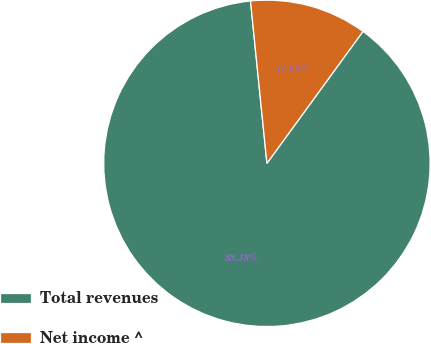<chart> <loc_0><loc_0><loc_500><loc_500><pie_chart><fcel>Total revenues<fcel>Net income ^<nl><fcel>88.38%<fcel>11.62%<nl></chart> 